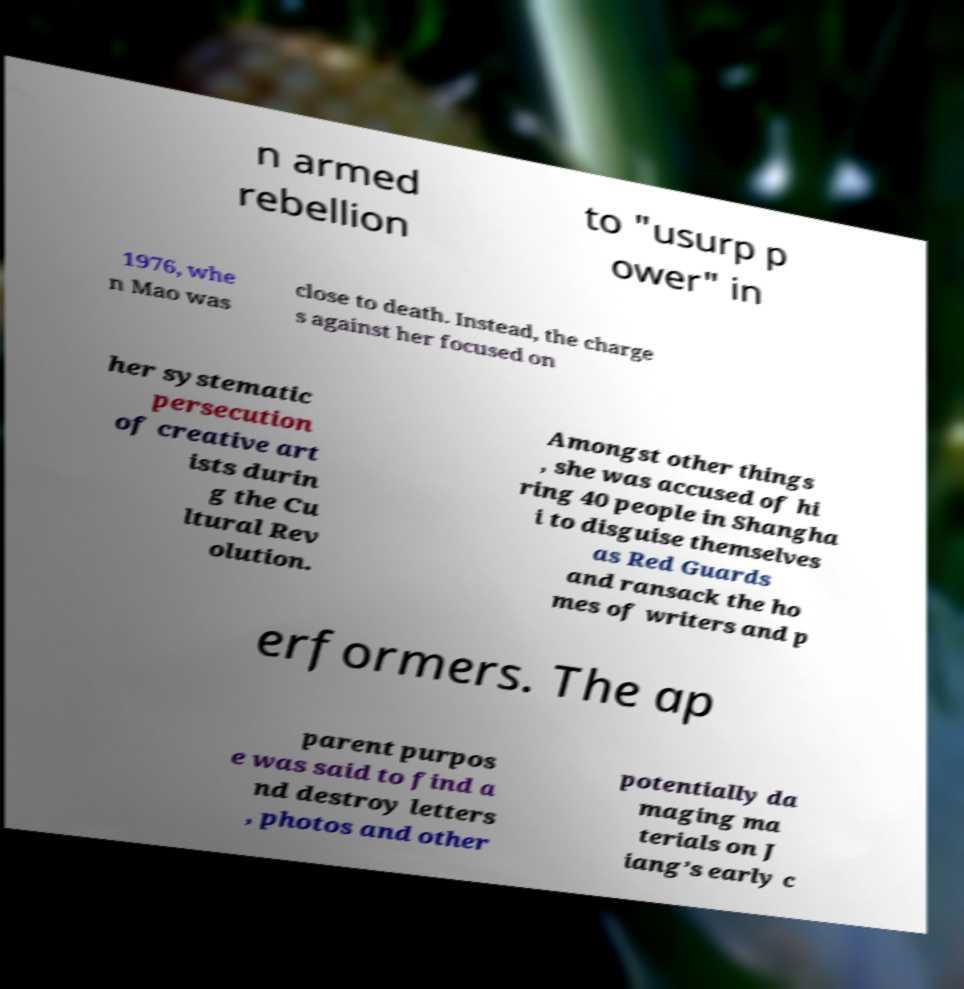I need the written content from this picture converted into text. Can you do that? n armed rebellion to "usurp p ower" in 1976, whe n Mao was close to death. Instead, the charge s against her focused on her systematic persecution of creative art ists durin g the Cu ltural Rev olution. Amongst other things , she was accused of hi ring 40 people in Shangha i to disguise themselves as Red Guards and ransack the ho mes of writers and p erformers. The ap parent purpos e was said to find a nd destroy letters , photos and other potentially da maging ma terials on J iang’s early c 